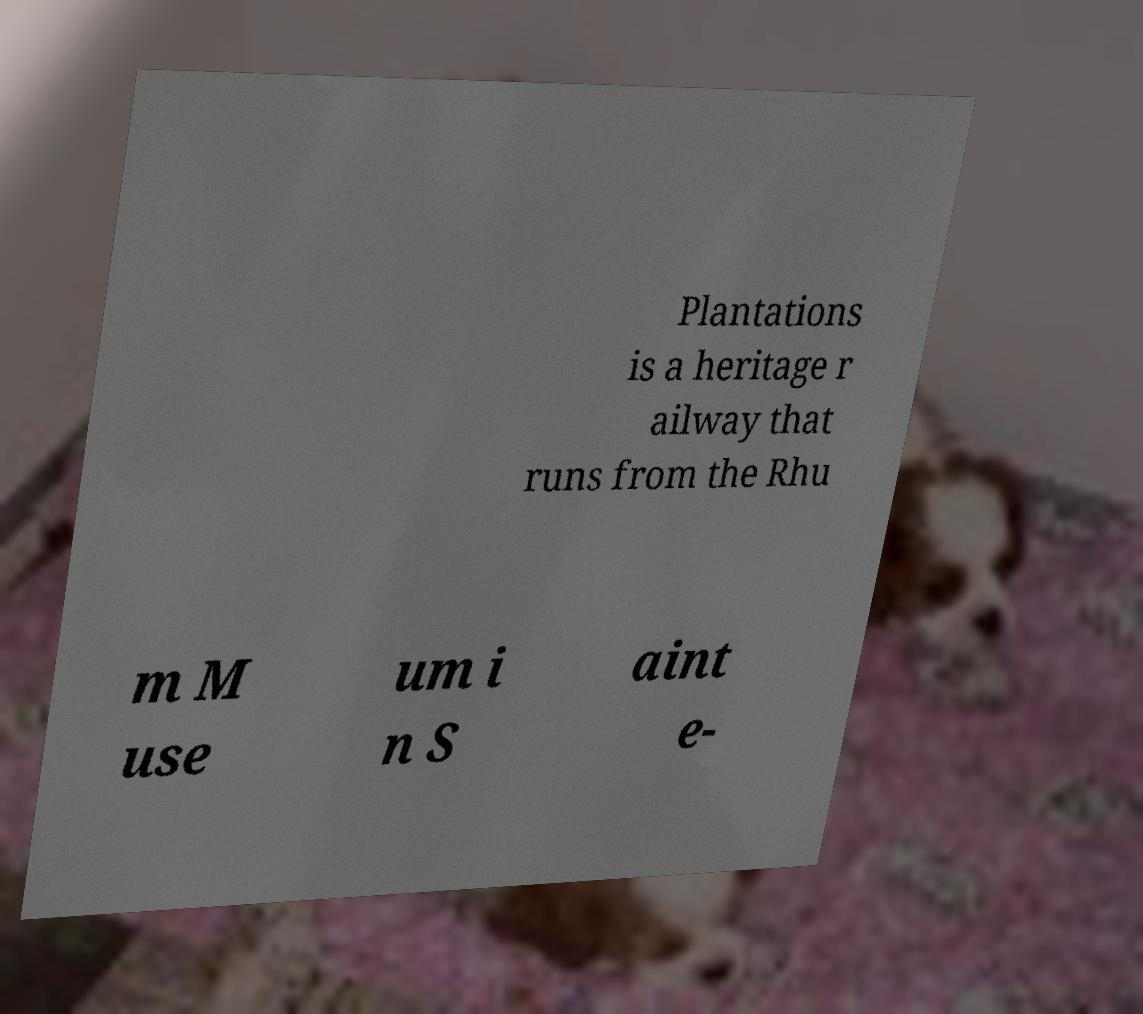Please read and relay the text visible in this image. What does it say? Plantations is a heritage r ailway that runs from the Rhu m M use um i n S aint e- 